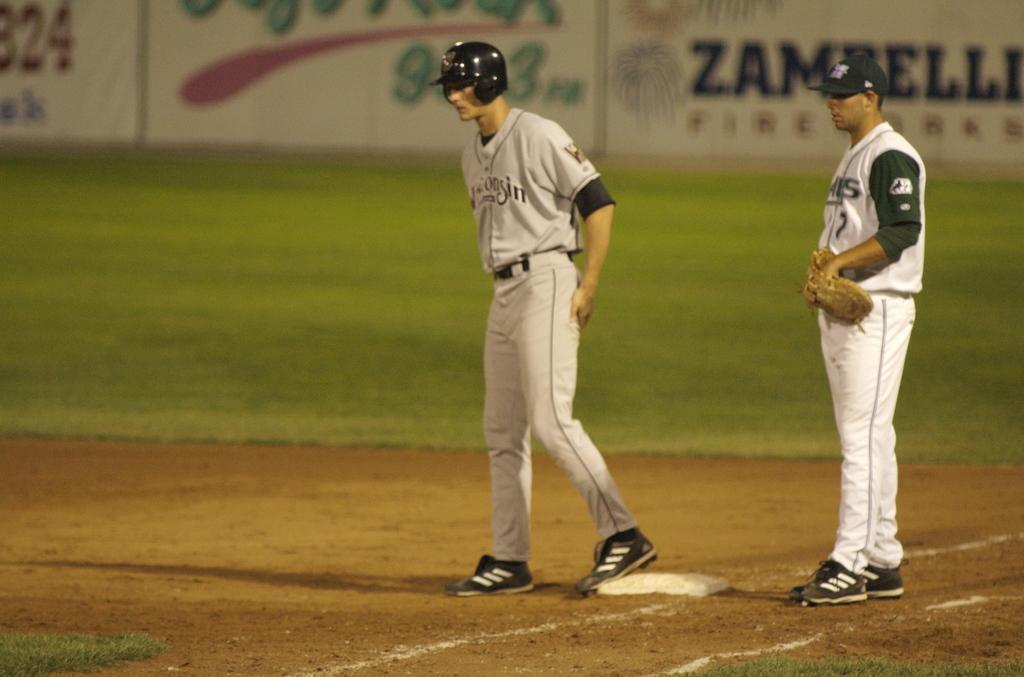How many persons are in the image? There are two persons standing in the image. What can be seen in the background of the image? There are boards and grass visible in the background of the image. What type of thrill can be seen happening behind the persons in the image? There is no specific thrill visible in the image; it only shows two persons standing and the background elements. Is there a veil covering any part of the image? No, there is no veil present in the image. 